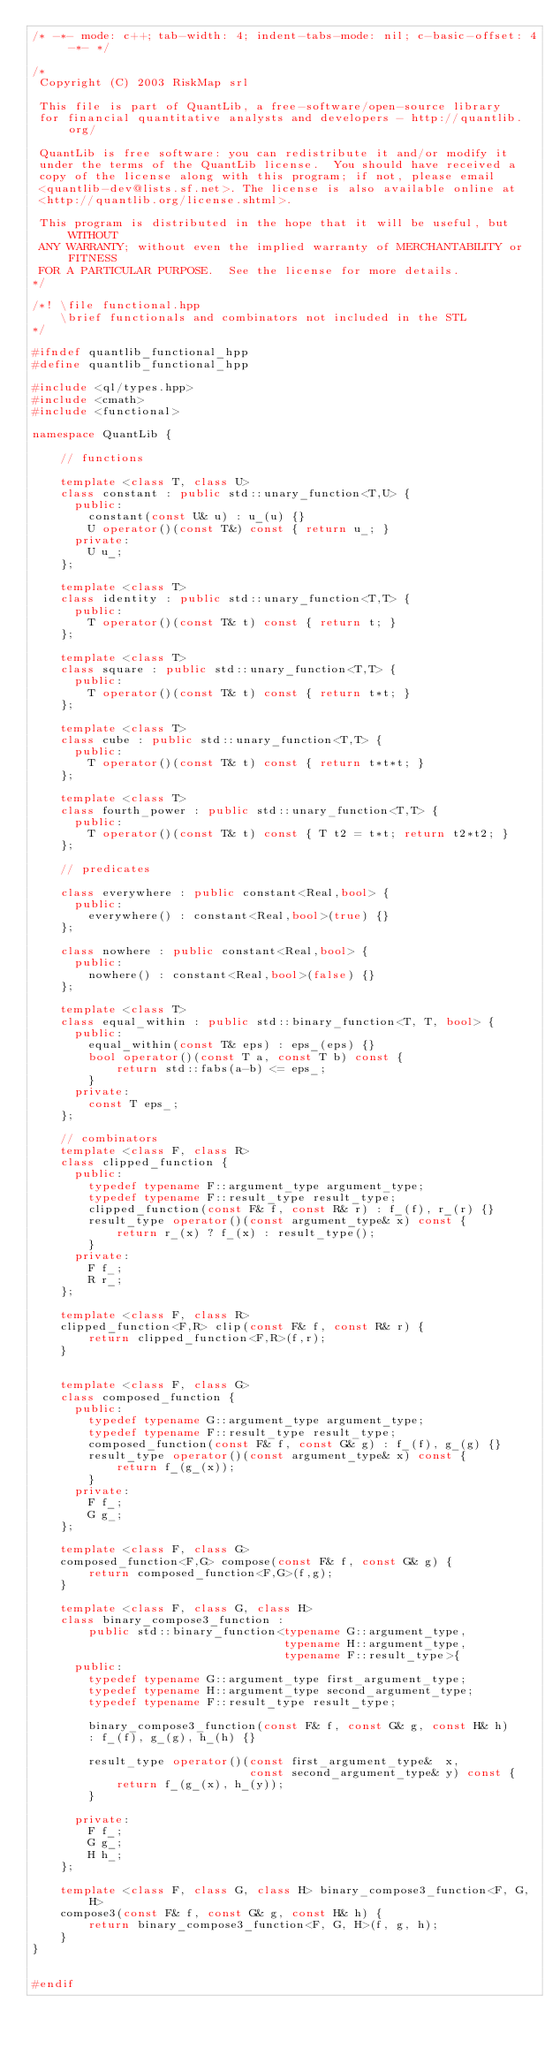<code> <loc_0><loc_0><loc_500><loc_500><_C++_>/* -*- mode: c++; tab-width: 4; indent-tabs-mode: nil; c-basic-offset: 4 -*- */

/*
 Copyright (C) 2003 RiskMap srl

 This file is part of QuantLib, a free-software/open-source library
 for financial quantitative analysts and developers - http://quantlib.org/

 QuantLib is free software: you can redistribute it and/or modify it
 under the terms of the QuantLib license.  You should have received a
 copy of the license along with this program; if not, please email
 <quantlib-dev@lists.sf.net>. The license is also available online at
 <http://quantlib.org/license.shtml>.

 This program is distributed in the hope that it will be useful, but WITHOUT
 ANY WARRANTY; without even the implied warranty of MERCHANTABILITY or FITNESS
 FOR A PARTICULAR PURPOSE.  See the license for more details.
*/

/*! \file functional.hpp
    \brief functionals and combinators not included in the STL
*/

#ifndef quantlib_functional_hpp
#define quantlib_functional_hpp

#include <ql/types.hpp>
#include <cmath>
#include <functional>

namespace QuantLib {

    // functions

    template <class T, class U>
    class constant : public std::unary_function<T,U> {
      public:
        constant(const U& u) : u_(u) {}
        U operator()(const T&) const { return u_; }
      private:
        U u_;
    };

    template <class T>
    class identity : public std::unary_function<T,T> {
      public:
        T operator()(const T& t) const { return t; }
    };

    template <class T>
    class square : public std::unary_function<T,T> {
      public:
        T operator()(const T& t) const { return t*t; }
    };

    template <class T>
    class cube : public std::unary_function<T,T> {
      public:
        T operator()(const T& t) const { return t*t*t; }
    };

    template <class T>
    class fourth_power : public std::unary_function<T,T> {
      public:
        T operator()(const T& t) const { T t2 = t*t; return t2*t2; }
    };

    // predicates

    class everywhere : public constant<Real,bool> {
      public:
        everywhere() : constant<Real,bool>(true) {}
    };

    class nowhere : public constant<Real,bool> {
      public:
        nowhere() : constant<Real,bool>(false) {}
    };

    template <class T>
    class equal_within : public std::binary_function<T, T, bool> {
      public:
        equal_within(const T& eps) : eps_(eps) {}
        bool operator()(const T a, const T b) const {
            return std::fabs(a-b) <= eps_;
        }
      private:
        const T eps_;
    };

    // combinators
    template <class F, class R>
    class clipped_function {
      public:
        typedef typename F::argument_type argument_type;
        typedef typename F::result_type result_type;
        clipped_function(const F& f, const R& r) : f_(f), r_(r) {}
        result_type operator()(const argument_type& x) const {
            return r_(x) ? f_(x) : result_type();
        }
      private:
        F f_;
        R r_;
    };

    template <class F, class R>
    clipped_function<F,R> clip(const F& f, const R& r) {
        return clipped_function<F,R>(f,r);
    }


    template <class F, class G>
    class composed_function {
      public:
        typedef typename G::argument_type argument_type;
        typedef typename F::result_type result_type;
        composed_function(const F& f, const G& g) : f_(f), g_(g) {}
        result_type operator()(const argument_type& x) const {
            return f_(g_(x));
        }
      private:
        F f_;
        G g_;
    };

    template <class F, class G>
    composed_function<F,G> compose(const F& f, const G& g) {
        return composed_function<F,G>(f,g);
    }

    template <class F, class G, class H>
    class binary_compose3_function :
        public std::binary_function<typename G::argument_type,
                                    typename H::argument_type,
                                    typename F::result_type>{
      public:
        typedef typename G::argument_type first_argument_type;
        typedef typename H::argument_type second_argument_type;
        typedef typename F::result_type result_type;

        binary_compose3_function(const F& f, const G& g, const H& h)
        : f_(f), g_(g), h_(h) {}

        result_type operator()(const first_argument_type&  x,
                               const second_argument_type& y) const {
            return f_(g_(x), h_(y));
        }

      private:
        F f_;
        G g_;
        H h_;
    };

    template <class F, class G, class H> binary_compose3_function<F, G, H>
    compose3(const F& f, const G& g, const H& h) {
        return binary_compose3_function<F, G, H>(f, g, h);
    }
}


#endif
</code> 